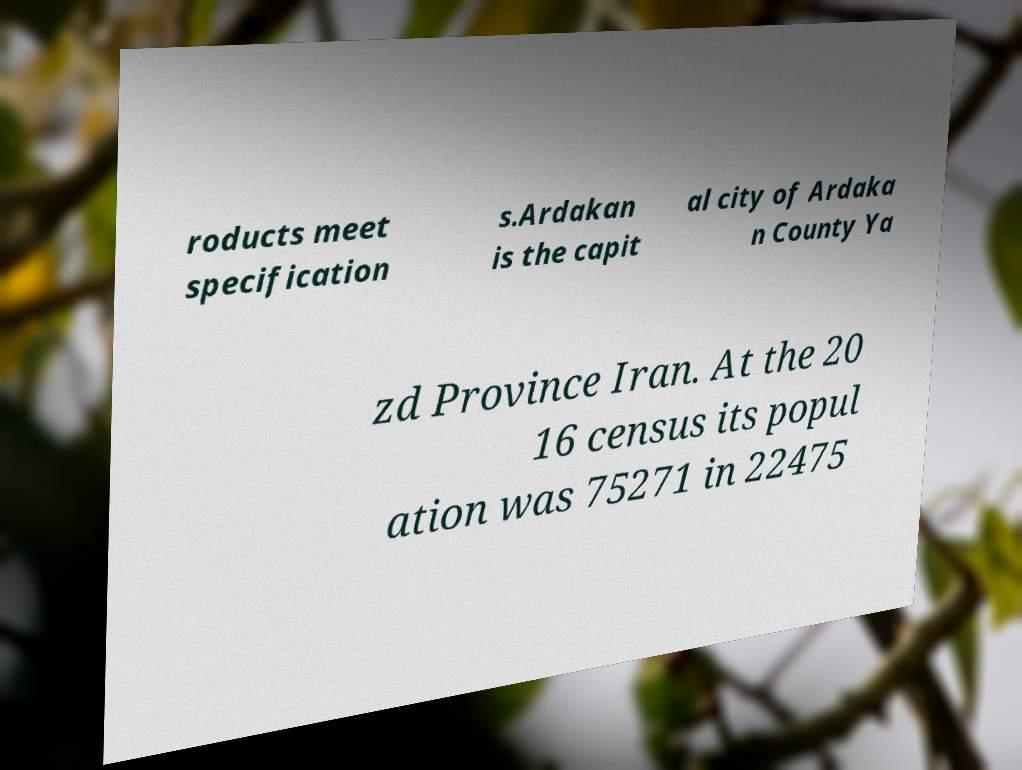Can you accurately transcribe the text from the provided image for me? roducts meet specification s.Ardakan is the capit al city of Ardaka n County Ya zd Province Iran. At the 20 16 census its popul ation was 75271 in 22475 